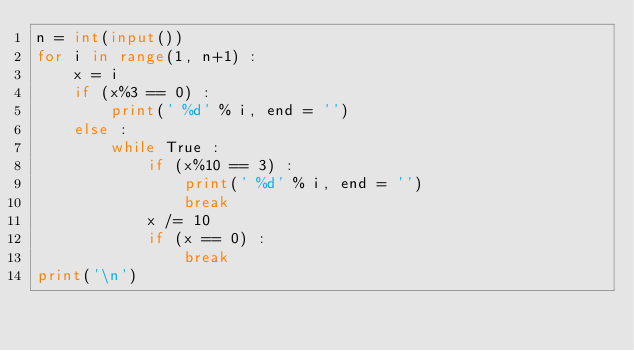<code> <loc_0><loc_0><loc_500><loc_500><_Python_>n = int(input())
for i in range(1, n+1) :
    x = i
    if (x%3 == 0) :
        print(' %d' % i, end = '')
    else :
        while True :
            if (x%10 == 3) :
                print(' %d' % i, end = '')
                break
            x /= 10
            if (x == 0) :
                break
print('\n')
</code> 